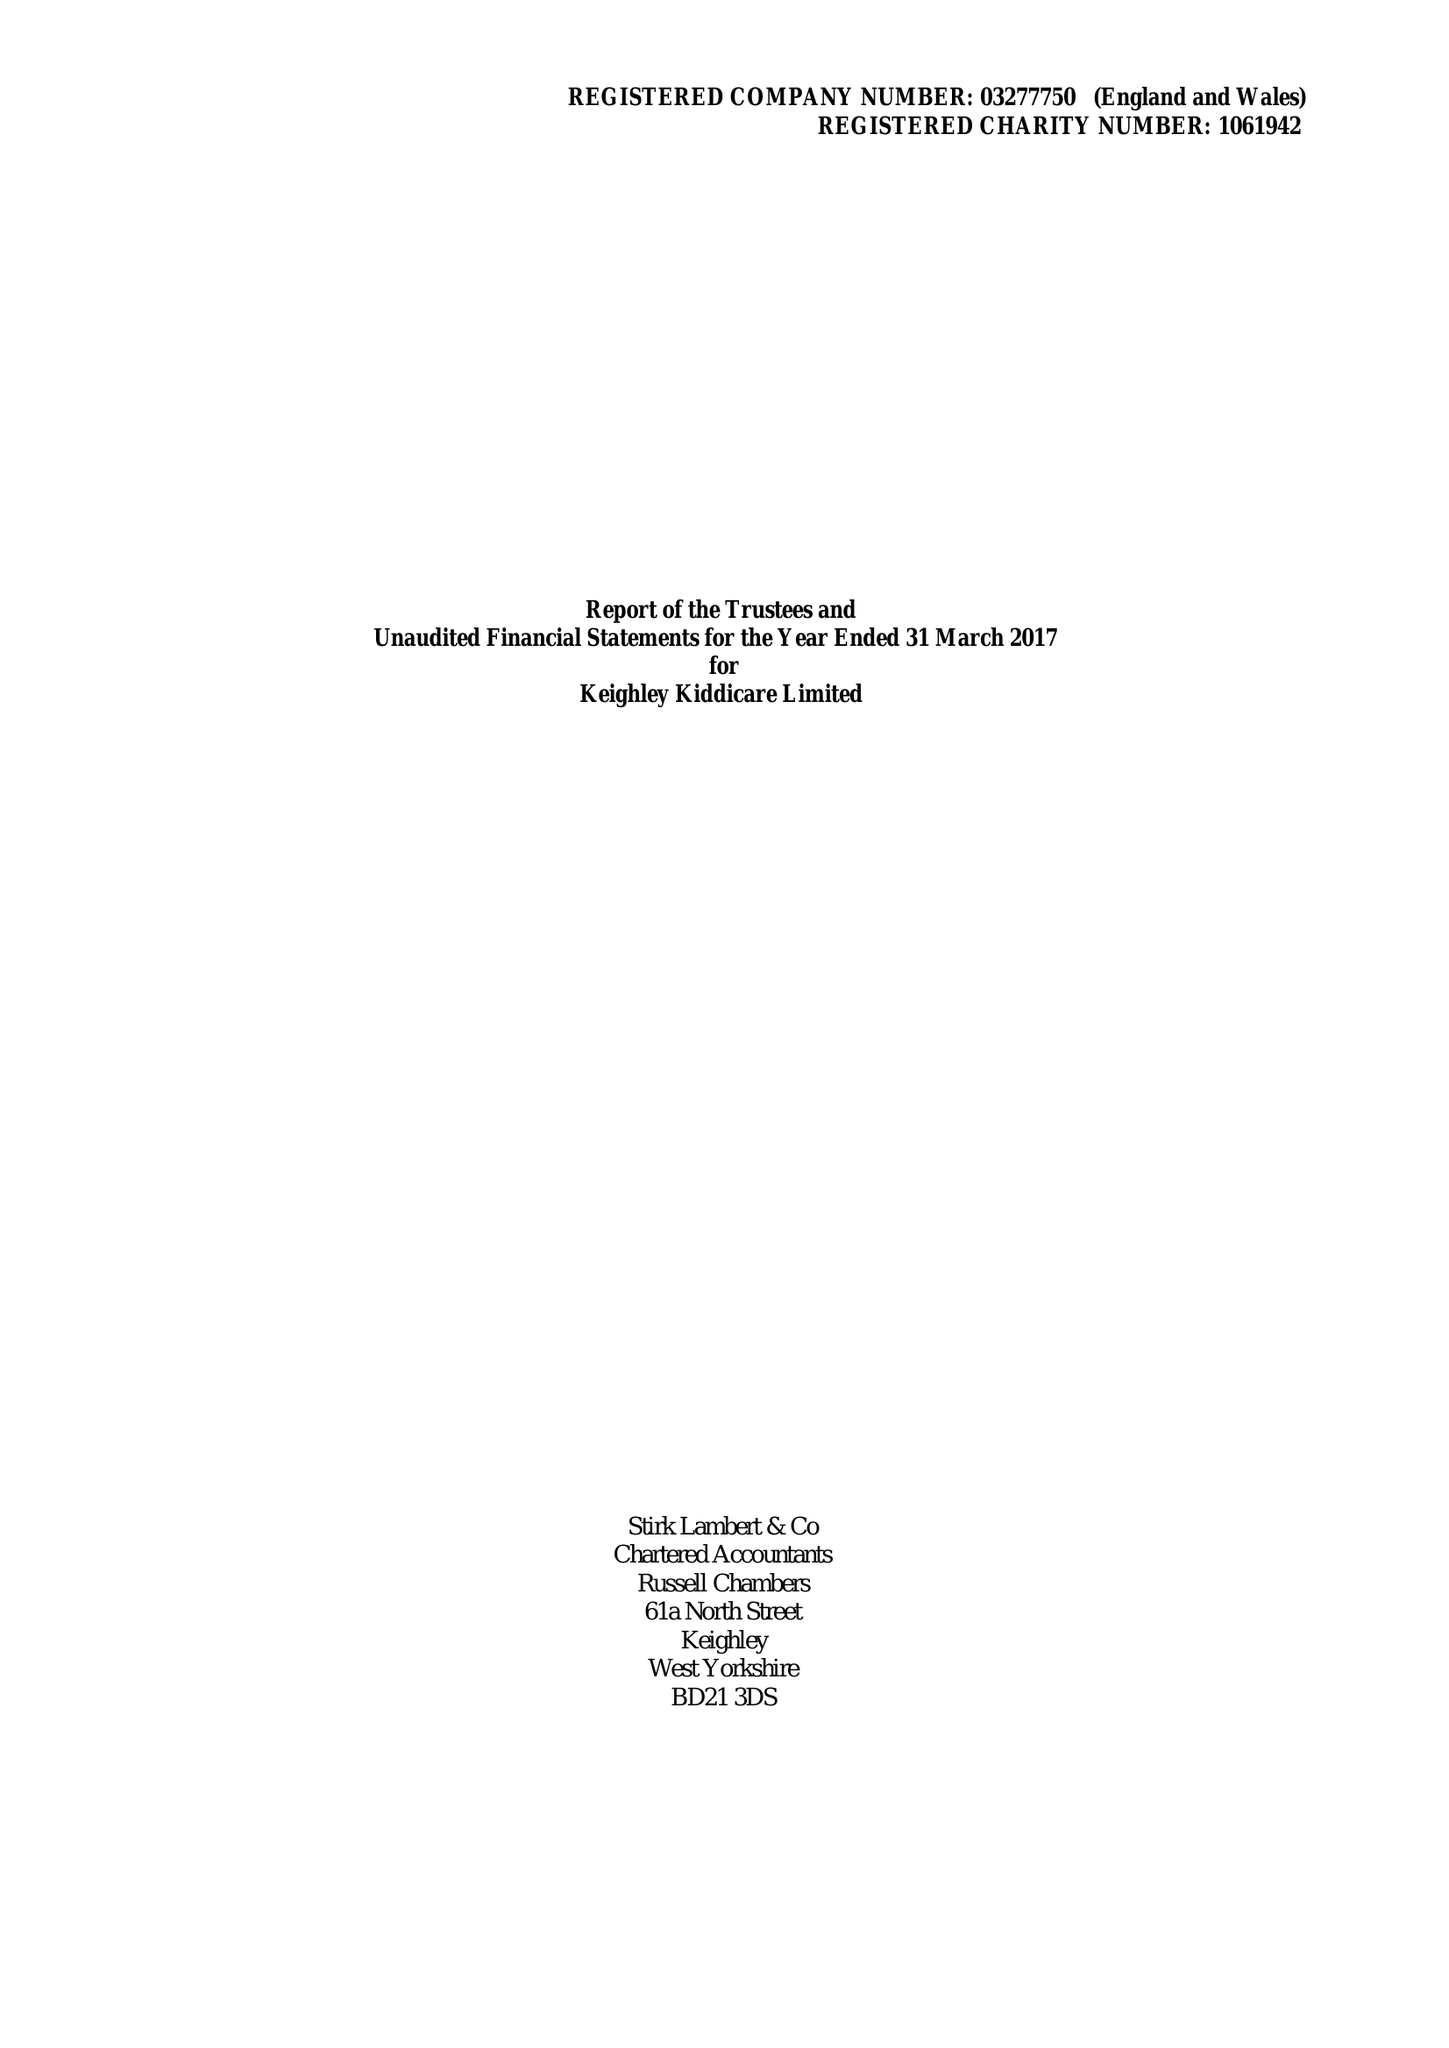What is the value for the report_date?
Answer the question using a single word or phrase. 2017-03-31 